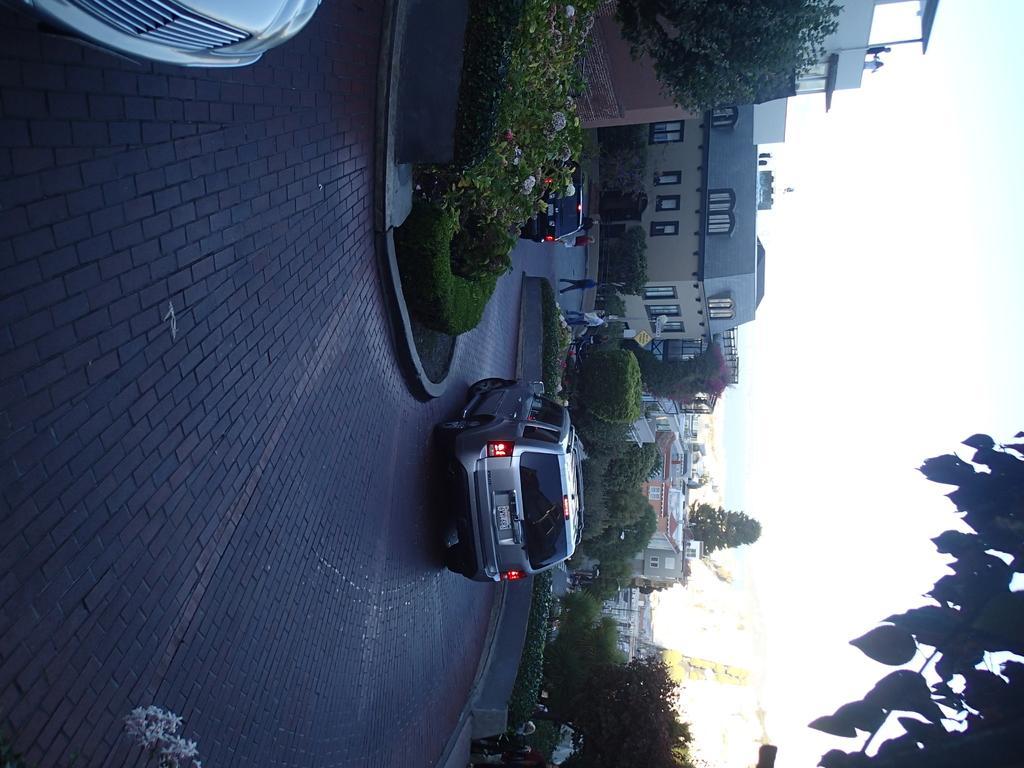Please provide a concise description of this image. In this image there are vehicles on the road. Top of the image there are plants having flowers. Few people are walking on the road. Background there are plants, buildings and trees. Right side there is sky. Right bottom there are branches having leaves. 